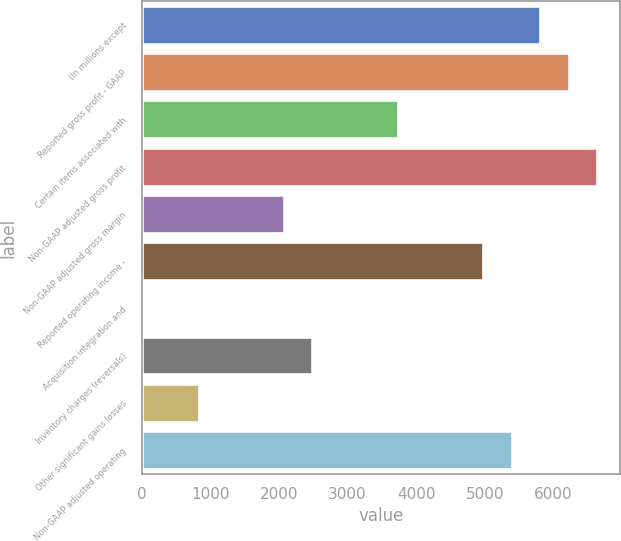Convert chart. <chart><loc_0><loc_0><loc_500><loc_500><bar_chart><fcel>(In millions except<fcel>Reported gross profit - GAAP<fcel>Certain items associated with<fcel>Non-GAAP adjusted gross profit<fcel>Non-GAAP adjusted gross margin<fcel>Reported operating income -<fcel>Acquisition integration and<fcel>Inventory charges (reversals)<fcel>Other significant gains losses<fcel>Non-GAAP adjusted operating<nl><fcel>5805<fcel>6219.5<fcel>3732.5<fcel>6634<fcel>2074.5<fcel>4976<fcel>2<fcel>2489<fcel>831<fcel>5390.5<nl></chart> 